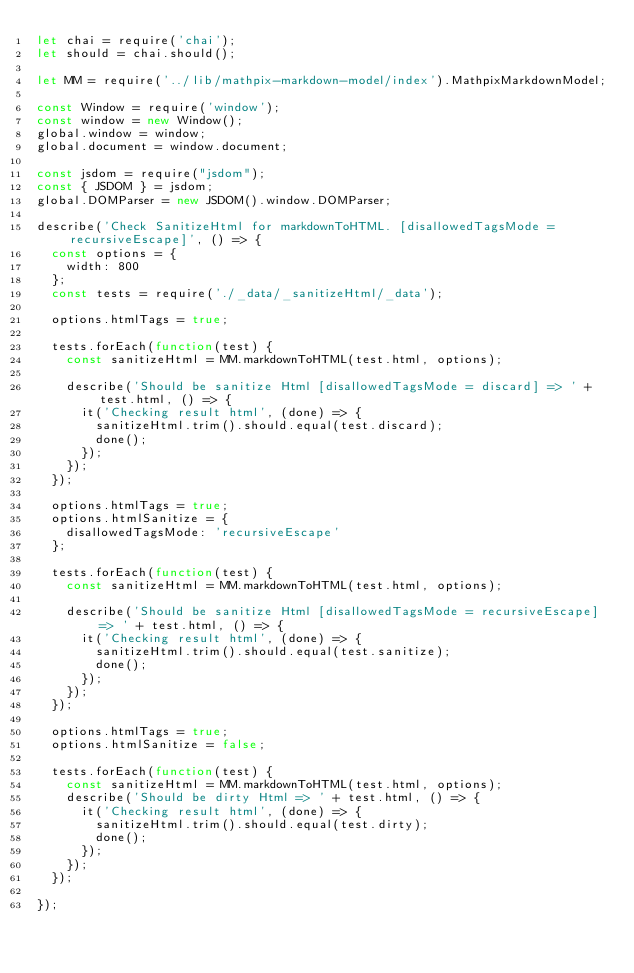Convert code to text. <code><loc_0><loc_0><loc_500><loc_500><_JavaScript_>let chai = require('chai');
let should = chai.should();

let MM = require('../lib/mathpix-markdown-model/index').MathpixMarkdownModel;

const Window = require('window');
const window = new Window();
global.window = window;
global.document = window.document;

const jsdom = require("jsdom");
const { JSDOM } = jsdom;
global.DOMParser = new JSDOM().window.DOMParser;

describe('Check SanitizeHtml for markdownToHTML. [disallowedTagsMode = recursiveEscape]', () => {
  const options = {
    width: 800
  };
  const tests = require('./_data/_sanitizeHtml/_data');

  options.htmlTags = true;

  tests.forEach(function(test) {
    const sanitizeHtml = MM.markdownToHTML(test.html, options);

    describe('Should be sanitize Html [disallowedTagsMode = discard] => ' + test.html, () => {
      it('Checking result html', (done) => {
        sanitizeHtml.trim().should.equal(test.discard);
        done();
      });
    });
  });

  options.htmlTags = true;
  options.htmlSanitize = {
    disallowedTagsMode: 'recursiveEscape'
  };

  tests.forEach(function(test) {
    const sanitizeHtml = MM.markdownToHTML(test.html, options);

    describe('Should be sanitize Html [disallowedTagsMode = recursiveEscape] => ' + test.html, () => {
      it('Checking result html', (done) => {
        sanitizeHtml.trim().should.equal(test.sanitize);
        done();
      });
    });
  });

  options.htmlTags = true;
  options.htmlSanitize = false;

  tests.forEach(function(test) {
    const sanitizeHtml = MM.markdownToHTML(test.html, options);
    describe('Should be dirty Html => ' + test.html, () => {
      it('Checking result html', (done) => {
        sanitizeHtml.trim().should.equal(test.dirty);
        done();
      });
    });
  });

});
</code> 